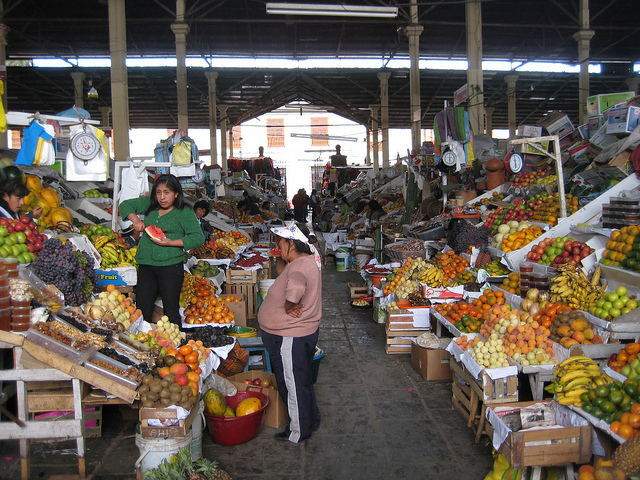Are there any non-food items being sold in the market? Yes, beyond the plentiful fruits and vegetables, there are items such as what appear to be earthenware pots and various household wares on offer in the background. These add to the diversity of goods available at the market. 